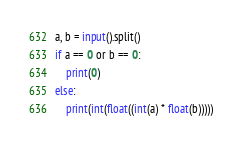Convert code to text. <code><loc_0><loc_0><loc_500><loc_500><_Python_>a, b = input().split()
if a == 0 or b == 0:
    print(0)
else:
    print(int(float((int(a) * float(b)))))</code> 